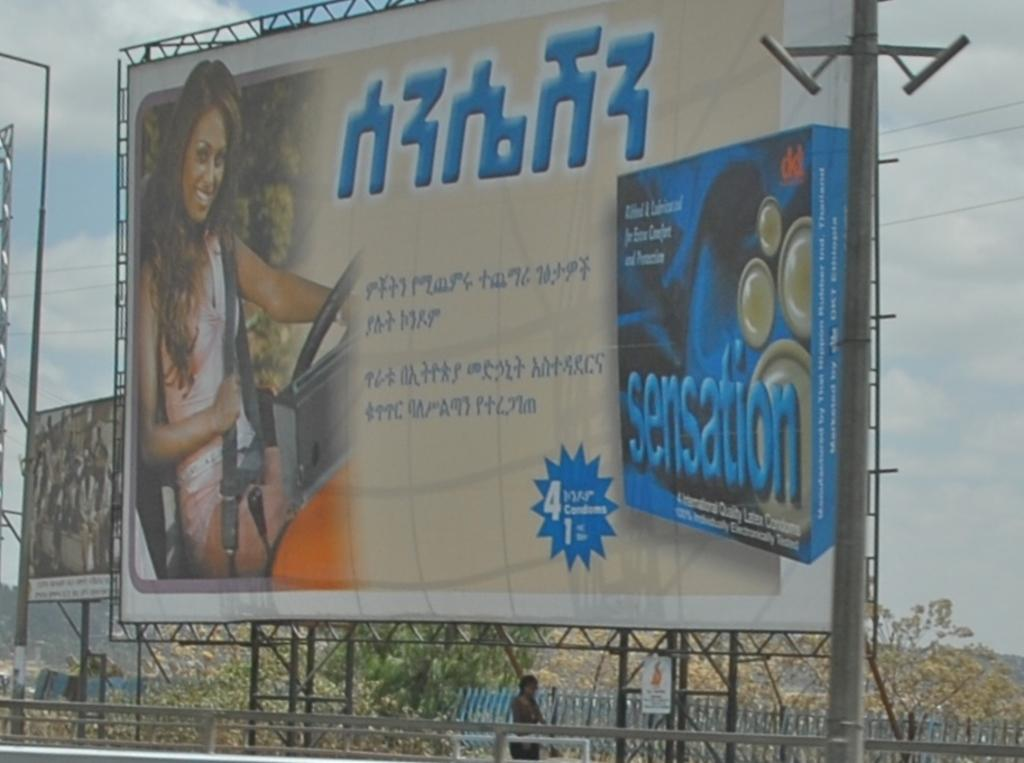<image>
Create a compact narrative representing the image presented. An ad for Sensation can be seen on the outdoor billboard 